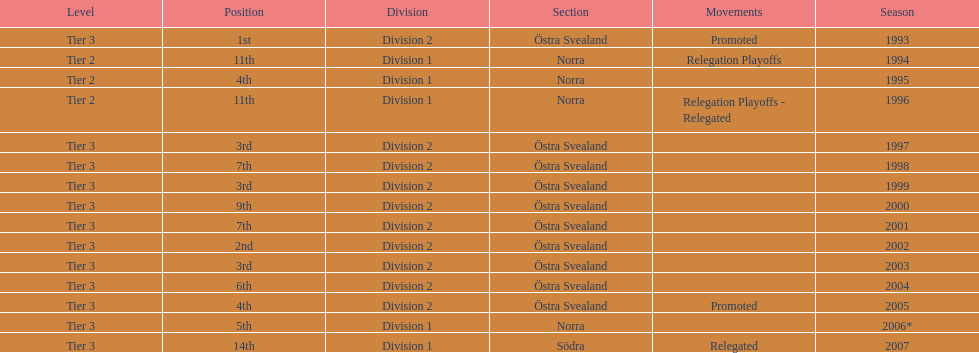Which year was more successful, 2007 or 2002? 2002. 